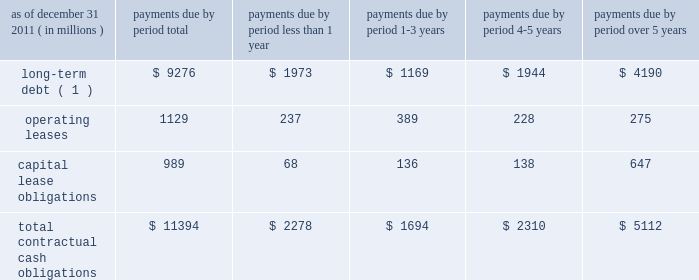We maintain an effective universal shelf registration that allows for the public offering and sale of debt securities , capital securities , common stock , depositary shares and preferred stock , and warrants to purchase such securities , including any shares into which the preferred stock and depositary shares may be convertible , or any combination thereof .
We have , as discussed previously , issued in the past , and we may issue in the future , securities pursuant to the shelf registration .
The issuance of debt or equity securities will depend on future market conditions , funding needs and other factors .
Additional information about debt and equity securities issued pursuant to this shelf registration is provided in notes 9 and 12 to the consolidated financial statements included under item 8 .
We currently maintain a corporate commercial paper program , under which we can issue up to $ 3 billion with original maturities of up to 270 days from the date of issue .
At december 31 , 2011 , we had $ 2.38 billion of commercial paper outstanding , compared to $ 2.80 billion at december 31 , 2010 .
Additional information about our corporate commercial paper program is provided in note 8 to the consolidated financial statements included under item 8 .
State street bank had initial board authority to issue bank notes up to an aggregate of $ 5 billion , including up to $ 1 billion of subordinated bank notes .
Approximately $ 2.05 billion was available under this board authority as of december 31 , 2011 .
In 2011 , $ 2.45 billion of senior notes , which were outstanding at december 31 , 2010 , matured .
State street bank currently maintains a line of credit with a financial institution of cad $ 800 million , or approximately $ 787 million as of december 31 , 2011 , to support its canadian securities processing operations .
The line of credit has no stated termination date and is cancelable by either party with prior notice .
As of december 31 , 2011 , no balance was outstanding on this line of credit .
Contractual cash obligations .
( 1 ) long-term debt excludes capital lease obligations ( presented as a separate line item ) and the effect of interest-rate swaps .
Interest payments were calculated at the stated rate with the exception of floating-rate debt , for which payments were calculated using the indexed rate in effect as of december 31 , 2011 .
The obligations presented in the table above are recorded in our consolidated statement of condition at december 31 , 2011 , except for interest on long-term debt and capital lease obligations .
The table does not include obligations which will be settled in cash , primarily in less than one year , such as deposits , federal funds purchased , securities sold under repurchase agreements and other short-term borrowings .
Additional information about deposits , federal funds purchased , securities sold under repurchase agreements and other short-term borrowings is provided in notes 7 and 8 to the consolidated financial statements included under item 8 .
The table does not include obligations related to derivative instruments , because the amounts included in our consolidated statement of condition at december 31 , 2011 related to derivatives do not represent the amounts that may ultimately be paid under the contracts upon settlement .
Additional information about derivative contracts is provided in note 16 to the consolidated financial statements included under item 8 .
We have obligations under pension and other post-retirement benefit plans , more fully described in note 18 to the consolidated financial statements included under item 8 , which are not included in the above table .
Additional information about contractual cash obligations related to long-term debt and operating and capital leases is provided in notes 9 and 19 to the consolidated financial statements included under item 8 .
The consolidated statement of cash flows , also included under item 8 , provides additional liquidity information. .
What percent of the total contractual cash obligations are due within the first year? 
Computations: (2278 / 11394)
Answer: 0.19993. 